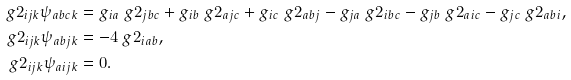Convert formula to latex. <formula><loc_0><loc_0><loc_500><loc_500>\ g 2 _ { i j k } \psi _ { a b c k } & = g _ { i a } \ g 2 _ { j b c } + g _ { i b } \ g 2 _ { a j c } + g _ { i c } \ g 2 _ { a b j } - g _ { j a } \ g 2 _ { i b c } - g _ { j b } \ g 2 _ { a i c } - g _ { j c } \ g 2 _ { a b i } , \\ \ g 2 _ { i j k } \psi _ { a b j k } & = - 4 \ g 2 _ { i a b } , \\ \ g 2 _ { i j k } \psi _ { a i j k } & = 0 .</formula> 